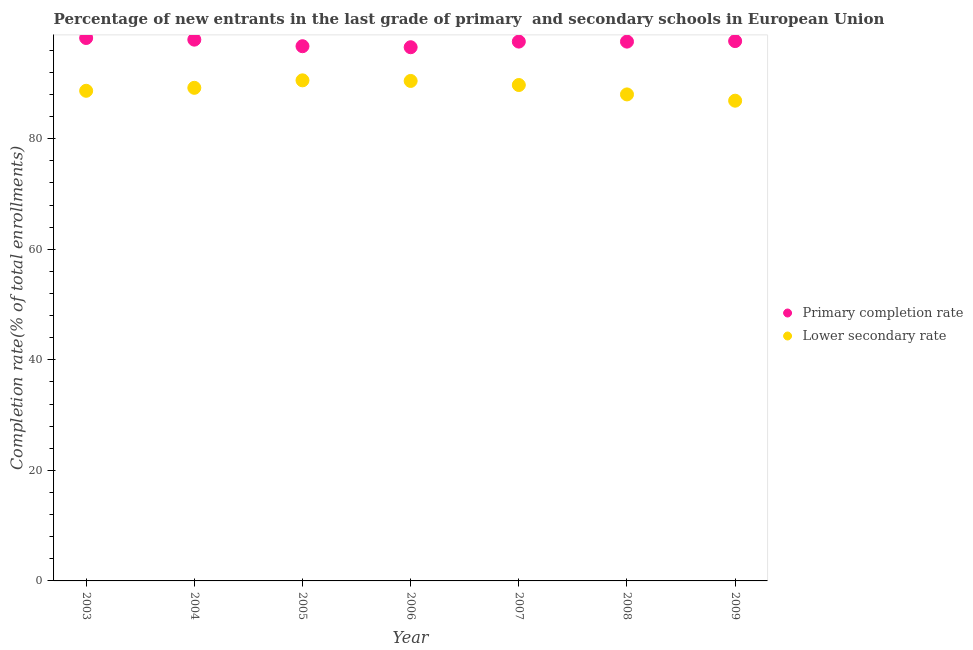What is the completion rate in primary schools in 2004?
Keep it short and to the point. 97.93. Across all years, what is the maximum completion rate in primary schools?
Provide a succinct answer. 98.23. Across all years, what is the minimum completion rate in primary schools?
Provide a succinct answer. 96.56. In which year was the completion rate in secondary schools maximum?
Offer a very short reply. 2005. In which year was the completion rate in primary schools minimum?
Give a very brief answer. 2006. What is the total completion rate in primary schools in the graph?
Provide a short and direct response. 682.29. What is the difference between the completion rate in secondary schools in 2006 and that in 2007?
Your answer should be compact. 0.74. What is the difference between the completion rate in primary schools in 2007 and the completion rate in secondary schools in 2004?
Keep it short and to the point. 8.36. What is the average completion rate in primary schools per year?
Make the answer very short. 97.47. In the year 2005, what is the difference between the completion rate in secondary schools and completion rate in primary schools?
Ensure brevity in your answer.  -6.18. What is the ratio of the completion rate in secondary schools in 2004 to that in 2005?
Provide a succinct answer. 0.99. Is the difference between the completion rate in primary schools in 2004 and 2005 greater than the difference between the completion rate in secondary schools in 2004 and 2005?
Your answer should be very brief. Yes. What is the difference between the highest and the second highest completion rate in primary schools?
Ensure brevity in your answer.  0.3. What is the difference between the highest and the lowest completion rate in primary schools?
Offer a terse response. 1.67. Is the sum of the completion rate in primary schools in 2003 and 2008 greater than the maximum completion rate in secondary schools across all years?
Provide a short and direct response. Yes. Is the completion rate in secondary schools strictly less than the completion rate in primary schools over the years?
Your answer should be very brief. Yes. How many years are there in the graph?
Give a very brief answer. 7. Are the values on the major ticks of Y-axis written in scientific E-notation?
Provide a succinct answer. No. Does the graph contain grids?
Offer a terse response. No. How many legend labels are there?
Offer a terse response. 2. What is the title of the graph?
Keep it short and to the point. Percentage of new entrants in the last grade of primary  and secondary schools in European Union. Does "% of GNI" appear as one of the legend labels in the graph?
Offer a very short reply. No. What is the label or title of the X-axis?
Your answer should be very brief. Year. What is the label or title of the Y-axis?
Provide a succinct answer. Completion rate(% of total enrollments). What is the Completion rate(% of total enrollments) of Primary completion rate in 2003?
Your answer should be very brief. 98.23. What is the Completion rate(% of total enrollments) of Lower secondary rate in 2003?
Give a very brief answer. 88.68. What is the Completion rate(% of total enrollments) in Primary completion rate in 2004?
Make the answer very short. 97.93. What is the Completion rate(% of total enrollments) in Lower secondary rate in 2004?
Your response must be concise. 89.21. What is the Completion rate(% of total enrollments) in Primary completion rate in 2005?
Provide a short and direct response. 96.74. What is the Completion rate(% of total enrollments) of Lower secondary rate in 2005?
Ensure brevity in your answer.  90.57. What is the Completion rate(% of total enrollments) in Primary completion rate in 2006?
Provide a short and direct response. 96.56. What is the Completion rate(% of total enrollments) of Lower secondary rate in 2006?
Your answer should be compact. 90.46. What is the Completion rate(% of total enrollments) of Primary completion rate in 2007?
Ensure brevity in your answer.  97.58. What is the Completion rate(% of total enrollments) of Lower secondary rate in 2007?
Make the answer very short. 89.72. What is the Completion rate(% of total enrollments) of Primary completion rate in 2008?
Give a very brief answer. 97.58. What is the Completion rate(% of total enrollments) of Lower secondary rate in 2008?
Offer a very short reply. 88.02. What is the Completion rate(% of total enrollments) in Primary completion rate in 2009?
Offer a terse response. 97.67. What is the Completion rate(% of total enrollments) of Lower secondary rate in 2009?
Provide a short and direct response. 86.89. Across all years, what is the maximum Completion rate(% of total enrollments) of Primary completion rate?
Provide a succinct answer. 98.23. Across all years, what is the maximum Completion rate(% of total enrollments) of Lower secondary rate?
Your response must be concise. 90.57. Across all years, what is the minimum Completion rate(% of total enrollments) of Primary completion rate?
Make the answer very short. 96.56. Across all years, what is the minimum Completion rate(% of total enrollments) in Lower secondary rate?
Your answer should be very brief. 86.89. What is the total Completion rate(% of total enrollments) in Primary completion rate in the graph?
Offer a very short reply. 682.29. What is the total Completion rate(% of total enrollments) in Lower secondary rate in the graph?
Your answer should be very brief. 623.55. What is the difference between the Completion rate(% of total enrollments) of Primary completion rate in 2003 and that in 2004?
Provide a short and direct response. 0.3. What is the difference between the Completion rate(% of total enrollments) in Lower secondary rate in 2003 and that in 2004?
Keep it short and to the point. -0.54. What is the difference between the Completion rate(% of total enrollments) of Primary completion rate in 2003 and that in 2005?
Provide a short and direct response. 1.48. What is the difference between the Completion rate(% of total enrollments) in Lower secondary rate in 2003 and that in 2005?
Provide a succinct answer. -1.89. What is the difference between the Completion rate(% of total enrollments) in Primary completion rate in 2003 and that in 2006?
Your answer should be compact. 1.67. What is the difference between the Completion rate(% of total enrollments) in Lower secondary rate in 2003 and that in 2006?
Your answer should be very brief. -1.78. What is the difference between the Completion rate(% of total enrollments) in Primary completion rate in 2003 and that in 2007?
Offer a very short reply. 0.65. What is the difference between the Completion rate(% of total enrollments) of Lower secondary rate in 2003 and that in 2007?
Your answer should be compact. -1.05. What is the difference between the Completion rate(% of total enrollments) of Primary completion rate in 2003 and that in 2008?
Your response must be concise. 0.65. What is the difference between the Completion rate(% of total enrollments) in Lower secondary rate in 2003 and that in 2008?
Keep it short and to the point. 0.65. What is the difference between the Completion rate(% of total enrollments) of Primary completion rate in 2003 and that in 2009?
Provide a short and direct response. 0.56. What is the difference between the Completion rate(% of total enrollments) in Lower secondary rate in 2003 and that in 2009?
Give a very brief answer. 1.79. What is the difference between the Completion rate(% of total enrollments) in Primary completion rate in 2004 and that in 2005?
Ensure brevity in your answer.  1.19. What is the difference between the Completion rate(% of total enrollments) in Lower secondary rate in 2004 and that in 2005?
Offer a terse response. -1.35. What is the difference between the Completion rate(% of total enrollments) of Primary completion rate in 2004 and that in 2006?
Ensure brevity in your answer.  1.37. What is the difference between the Completion rate(% of total enrollments) of Lower secondary rate in 2004 and that in 2006?
Your answer should be compact. -1.25. What is the difference between the Completion rate(% of total enrollments) of Primary completion rate in 2004 and that in 2007?
Ensure brevity in your answer.  0.35. What is the difference between the Completion rate(% of total enrollments) in Lower secondary rate in 2004 and that in 2007?
Give a very brief answer. -0.51. What is the difference between the Completion rate(% of total enrollments) in Primary completion rate in 2004 and that in 2008?
Offer a very short reply. 0.35. What is the difference between the Completion rate(% of total enrollments) of Lower secondary rate in 2004 and that in 2008?
Give a very brief answer. 1.19. What is the difference between the Completion rate(% of total enrollments) in Primary completion rate in 2004 and that in 2009?
Your answer should be compact. 0.26. What is the difference between the Completion rate(% of total enrollments) in Lower secondary rate in 2004 and that in 2009?
Keep it short and to the point. 2.33. What is the difference between the Completion rate(% of total enrollments) of Primary completion rate in 2005 and that in 2006?
Your answer should be very brief. 0.19. What is the difference between the Completion rate(% of total enrollments) of Lower secondary rate in 2005 and that in 2006?
Offer a terse response. 0.11. What is the difference between the Completion rate(% of total enrollments) of Primary completion rate in 2005 and that in 2007?
Give a very brief answer. -0.83. What is the difference between the Completion rate(% of total enrollments) in Lower secondary rate in 2005 and that in 2007?
Offer a terse response. 0.85. What is the difference between the Completion rate(% of total enrollments) of Primary completion rate in 2005 and that in 2008?
Offer a very short reply. -0.83. What is the difference between the Completion rate(% of total enrollments) of Lower secondary rate in 2005 and that in 2008?
Provide a succinct answer. 2.55. What is the difference between the Completion rate(% of total enrollments) in Primary completion rate in 2005 and that in 2009?
Your response must be concise. -0.93. What is the difference between the Completion rate(% of total enrollments) of Lower secondary rate in 2005 and that in 2009?
Make the answer very short. 3.68. What is the difference between the Completion rate(% of total enrollments) of Primary completion rate in 2006 and that in 2007?
Your response must be concise. -1.02. What is the difference between the Completion rate(% of total enrollments) in Lower secondary rate in 2006 and that in 2007?
Provide a short and direct response. 0.74. What is the difference between the Completion rate(% of total enrollments) of Primary completion rate in 2006 and that in 2008?
Offer a terse response. -1.02. What is the difference between the Completion rate(% of total enrollments) of Lower secondary rate in 2006 and that in 2008?
Provide a short and direct response. 2.44. What is the difference between the Completion rate(% of total enrollments) in Primary completion rate in 2006 and that in 2009?
Give a very brief answer. -1.11. What is the difference between the Completion rate(% of total enrollments) of Lower secondary rate in 2006 and that in 2009?
Provide a short and direct response. 3.57. What is the difference between the Completion rate(% of total enrollments) of Primary completion rate in 2007 and that in 2008?
Keep it short and to the point. 0. What is the difference between the Completion rate(% of total enrollments) in Lower secondary rate in 2007 and that in 2008?
Provide a succinct answer. 1.7. What is the difference between the Completion rate(% of total enrollments) in Primary completion rate in 2007 and that in 2009?
Your answer should be very brief. -0.09. What is the difference between the Completion rate(% of total enrollments) of Lower secondary rate in 2007 and that in 2009?
Your answer should be compact. 2.84. What is the difference between the Completion rate(% of total enrollments) in Primary completion rate in 2008 and that in 2009?
Give a very brief answer. -0.09. What is the difference between the Completion rate(% of total enrollments) of Lower secondary rate in 2008 and that in 2009?
Offer a very short reply. 1.14. What is the difference between the Completion rate(% of total enrollments) of Primary completion rate in 2003 and the Completion rate(% of total enrollments) of Lower secondary rate in 2004?
Provide a succinct answer. 9.01. What is the difference between the Completion rate(% of total enrollments) in Primary completion rate in 2003 and the Completion rate(% of total enrollments) in Lower secondary rate in 2005?
Your answer should be very brief. 7.66. What is the difference between the Completion rate(% of total enrollments) of Primary completion rate in 2003 and the Completion rate(% of total enrollments) of Lower secondary rate in 2006?
Provide a short and direct response. 7.77. What is the difference between the Completion rate(% of total enrollments) in Primary completion rate in 2003 and the Completion rate(% of total enrollments) in Lower secondary rate in 2007?
Give a very brief answer. 8.5. What is the difference between the Completion rate(% of total enrollments) of Primary completion rate in 2003 and the Completion rate(% of total enrollments) of Lower secondary rate in 2008?
Provide a succinct answer. 10.21. What is the difference between the Completion rate(% of total enrollments) of Primary completion rate in 2003 and the Completion rate(% of total enrollments) of Lower secondary rate in 2009?
Give a very brief answer. 11.34. What is the difference between the Completion rate(% of total enrollments) of Primary completion rate in 2004 and the Completion rate(% of total enrollments) of Lower secondary rate in 2005?
Offer a very short reply. 7.36. What is the difference between the Completion rate(% of total enrollments) in Primary completion rate in 2004 and the Completion rate(% of total enrollments) in Lower secondary rate in 2006?
Your answer should be compact. 7.47. What is the difference between the Completion rate(% of total enrollments) of Primary completion rate in 2004 and the Completion rate(% of total enrollments) of Lower secondary rate in 2007?
Offer a terse response. 8.21. What is the difference between the Completion rate(% of total enrollments) of Primary completion rate in 2004 and the Completion rate(% of total enrollments) of Lower secondary rate in 2008?
Ensure brevity in your answer.  9.91. What is the difference between the Completion rate(% of total enrollments) in Primary completion rate in 2004 and the Completion rate(% of total enrollments) in Lower secondary rate in 2009?
Offer a terse response. 11.05. What is the difference between the Completion rate(% of total enrollments) of Primary completion rate in 2005 and the Completion rate(% of total enrollments) of Lower secondary rate in 2006?
Your answer should be compact. 6.28. What is the difference between the Completion rate(% of total enrollments) in Primary completion rate in 2005 and the Completion rate(% of total enrollments) in Lower secondary rate in 2007?
Your answer should be compact. 7.02. What is the difference between the Completion rate(% of total enrollments) of Primary completion rate in 2005 and the Completion rate(% of total enrollments) of Lower secondary rate in 2008?
Offer a very short reply. 8.72. What is the difference between the Completion rate(% of total enrollments) in Primary completion rate in 2005 and the Completion rate(% of total enrollments) in Lower secondary rate in 2009?
Provide a succinct answer. 9.86. What is the difference between the Completion rate(% of total enrollments) in Primary completion rate in 2006 and the Completion rate(% of total enrollments) in Lower secondary rate in 2007?
Offer a very short reply. 6.84. What is the difference between the Completion rate(% of total enrollments) in Primary completion rate in 2006 and the Completion rate(% of total enrollments) in Lower secondary rate in 2008?
Your answer should be very brief. 8.54. What is the difference between the Completion rate(% of total enrollments) in Primary completion rate in 2006 and the Completion rate(% of total enrollments) in Lower secondary rate in 2009?
Make the answer very short. 9.67. What is the difference between the Completion rate(% of total enrollments) in Primary completion rate in 2007 and the Completion rate(% of total enrollments) in Lower secondary rate in 2008?
Your answer should be compact. 9.56. What is the difference between the Completion rate(% of total enrollments) in Primary completion rate in 2007 and the Completion rate(% of total enrollments) in Lower secondary rate in 2009?
Provide a short and direct response. 10.69. What is the difference between the Completion rate(% of total enrollments) of Primary completion rate in 2008 and the Completion rate(% of total enrollments) of Lower secondary rate in 2009?
Offer a very short reply. 10.69. What is the average Completion rate(% of total enrollments) in Primary completion rate per year?
Keep it short and to the point. 97.47. What is the average Completion rate(% of total enrollments) of Lower secondary rate per year?
Your response must be concise. 89.08. In the year 2003, what is the difference between the Completion rate(% of total enrollments) of Primary completion rate and Completion rate(% of total enrollments) of Lower secondary rate?
Offer a terse response. 9.55. In the year 2004, what is the difference between the Completion rate(% of total enrollments) of Primary completion rate and Completion rate(% of total enrollments) of Lower secondary rate?
Offer a very short reply. 8.72. In the year 2005, what is the difference between the Completion rate(% of total enrollments) of Primary completion rate and Completion rate(% of total enrollments) of Lower secondary rate?
Provide a short and direct response. 6.18. In the year 2006, what is the difference between the Completion rate(% of total enrollments) of Primary completion rate and Completion rate(% of total enrollments) of Lower secondary rate?
Your answer should be very brief. 6.1. In the year 2007, what is the difference between the Completion rate(% of total enrollments) of Primary completion rate and Completion rate(% of total enrollments) of Lower secondary rate?
Ensure brevity in your answer.  7.86. In the year 2008, what is the difference between the Completion rate(% of total enrollments) of Primary completion rate and Completion rate(% of total enrollments) of Lower secondary rate?
Ensure brevity in your answer.  9.55. In the year 2009, what is the difference between the Completion rate(% of total enrollments) in Primary completion rate and Completion rate(% of total enrollments) in Lower secondary rate?
Provide a succinct answer. 10.78. What is the ratio of the Completion rate(% of total enrollments) of Lower secondary rate in 2003 to that in 2004?
Your answer should be compact. 0.99. What is the ratio of the Completion rate(% of total enrollments) in Primary completion rate in 2003 to that in 2005?
Offer a terse response. 1.02. What is the ratio of the Completion rate(% of total enrollments) of Lower secondary rate in 2003 to that in 2005?
Offer a terse response. 0.98. What is the ratio of the Completion rate(% of total enrollments) in Primary completion rate in 2003 to that in 2006?
Provide a succinct answer. 1.02. What is the ratio of the Completion rate(% of total enrollments) in Lower secondary rate in 2003 to that in 2006?
Make the answer very short. 0.98. What is the ratio of the Completion rate(% of total enrollments) of Primary completion rate in 2003 to that in 2007?
Your answer should be compact. 1.01. What is the ratio of the Completion rate(% of total enrollments) of Lower secondary rate in 2003 to that in 2007?
Your answer should be compact. 0.99. What is the ratio of the Completion rate(% of total enrollments) of Lower secondary rate in 2003 to that in 2008?
Your answer should be compact. 1.01. What is the ratio of the Completion rate(% of total enrollments) of Lower secondary rate in 2003 to that in 2009?
Offer a terse response. 1.02. What is the ratio of the Completion rate(% of total enrollments) of Primary completion rate in 2004 to that in 2005?
Your response must be concise. 1.01. What is the ratio of the Completion rate(% of total enrollments) of Primary completion rate in 2004 to that in 2006?
Provide a short and direct response. 1.01. What is the ratio of the Completion rate(% of total enrollments) in Lower secondary rate in 2004 to that in 2006?
Provide a succinct answer. 0.99. What is the ratio of the Completion rate(% of total enrollments) in Lower secondary rate in 2004 to that in 2008?
Keep it short and to the point. 1.01. What is the ratio of the Completion rate(% of total enrollments) in Primary completion rate in 2004 to that in 2009?
Provide a succinct answer. 1. What is the ratio of the Completion rate(% of total enrollments) of Lower secondary rate in 2004 to that in 2009?
Keep it short and to the point. 1.03. What is the ratio of the Completion rate(% of total enrollments) in Lower secondary rate in 2005 to that in 2006?
Offer a very short reply. 1. What is the ratio of the Completion rate(% of total enrollments) in Primary completion rate in 2005 to that in 2007?
Your answer should be very brief. 0.99. What is the ratio of the Completion rate(% of total enrollments) of Lower secondary rate in 2005 to that in 2007?
Make the answer very short. 1.01. What is the ratio of the Completion rate(% of total enrollments) in Primary completion rate in 2005 to that in 2008?
Make the answer very short. 0.99. What is the ratio of the Completion rate(% of total enrollments) in Lower secondary rate in 2005 to that in 2008?
Give a very brief answer. 1.03. What is the ratio of the Completion rate(% of total enrollments) of Lower secondary rate in 2005 to that in 2009?
Your response must be concise. 1.04. What is the ratio of the Completion rate(% of total enrollments) of Primary completion rate in 2006 to that in 2007?
Make the answer very short. 0.99. What is the ratio of the Completion rate(% of total enrollments) in Lower secondary rate in 2006 to that in 2007?
Provide a short and direct response. 1.01. What is the ratio of the Completion rate(% of total enrollments) in Primary completion rate in 2006 to that in 2008?
Keep it short and to the point. 0.99. What is the ratio of the Completion rate(% of total enrollments) of Lower secondary rate in 2006 to that in 2008?
Offer a terse response. 1.03. What is the ratio of the Completion rate(% of total enrollments) of Lower secondary rate in 2006 to that in 2009?
Your answer should be very brief. 1.04. What is the ratio of the Completion rate(% of total enrollments) of Lower secondary rate in 2007 to that in 2008?
Provide a succinct answer. 1.02. What is the ratio of the Completion rate(% of total enrollments) in Primary completion rate in 2007 to that in 2009?
Provide a short and direct response. 1. What is the ratio of the Completion rate(% of total enrollments) of Lower secondary rate in 2007 to that in 2009?
Ensure brevity in your answer.  1.03. What is the ratio of the Completion rate(% of total enrollments) of Lower secondary rate in 2008 to that in 2009?
Provide a short and direct response. 1.01. What is the difference between the highest and the second highest Completion rate(% of total enrollments) in Primary completion rate?
Offer a very short reply. 0.3. What is the difference between the highest and the second highest Completion rate(% of total enrollments) in Lower secondary rate?
Provide a short and direct response. 0.11. What is the difference between the highest and the lowest Completion rate(% of total enrollments) in Primary completion rate?
Your answer should be very brief. 1.67. What is the difference between the highest and the lowest Completion rate(% of total enrollments) in Lower secondary rate?
Keep it short and to the point. 3.68. 